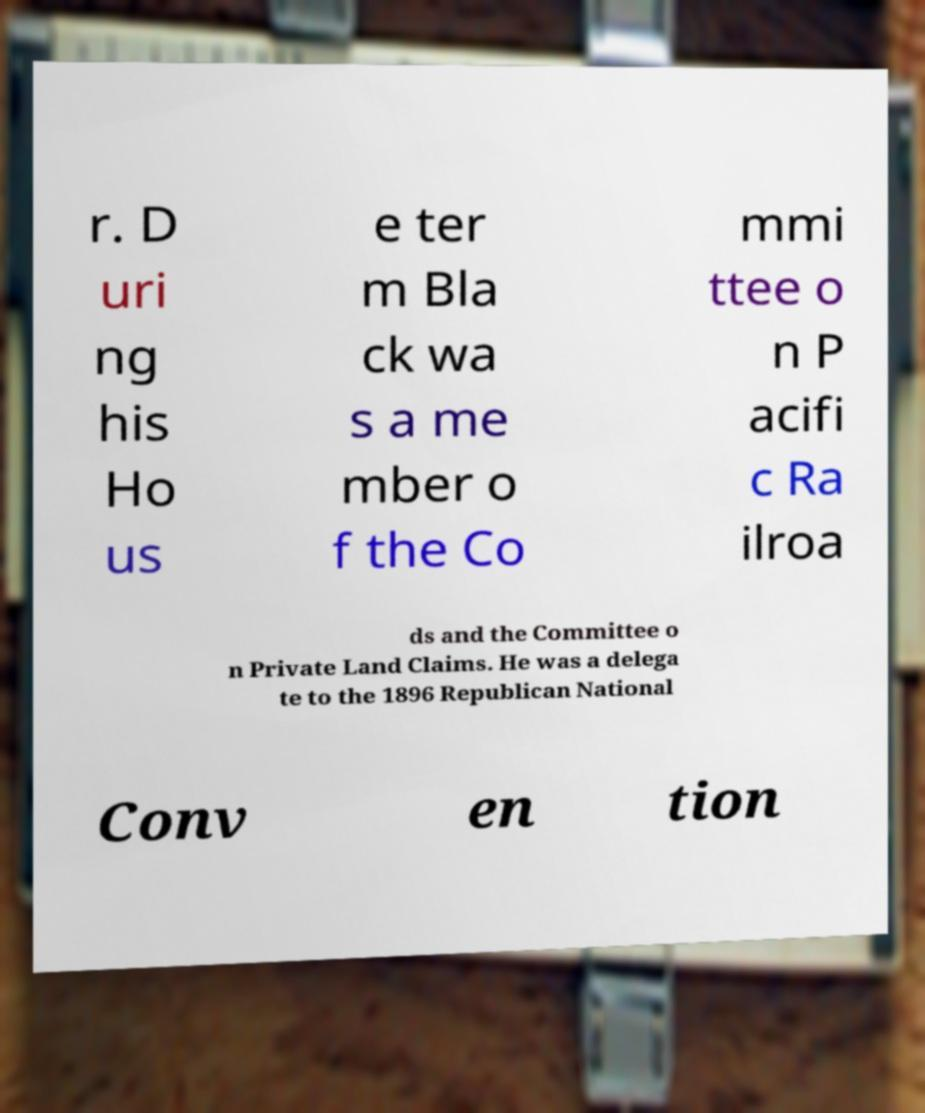I need the written content from this picture converted into text. Can you do that? r. D uri ng his Ho us e ter m Bla ck wa s a me mber o f the Co mmi ttee o n P acifi c Ra ilroa ds and the Committee o n Private Land Claims. He was a delega te to the 1896 Republican National Conv en tion 